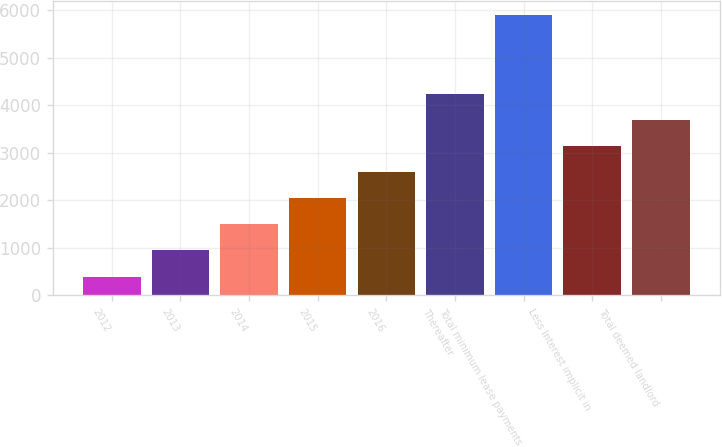Convert chart. <chart><loc_0><loc_0><loc_500><loc_500><bar_chart><fcel>2012<fcel>2013<fcel>2014<fcel>2015<fcel>2016<fcel>Thereafter<fcel>Total minimum lease payments<fcel>Less Interest implicit in<fcel>Total deemed landlord<nl><fcel>394<fcel>944.4<fcel>1494.8<fcel>2045.2<fcel>2595.6<fcel>4246.8<fcel>5898<fcel>3146<fcel>3696.4<nl></chart> 